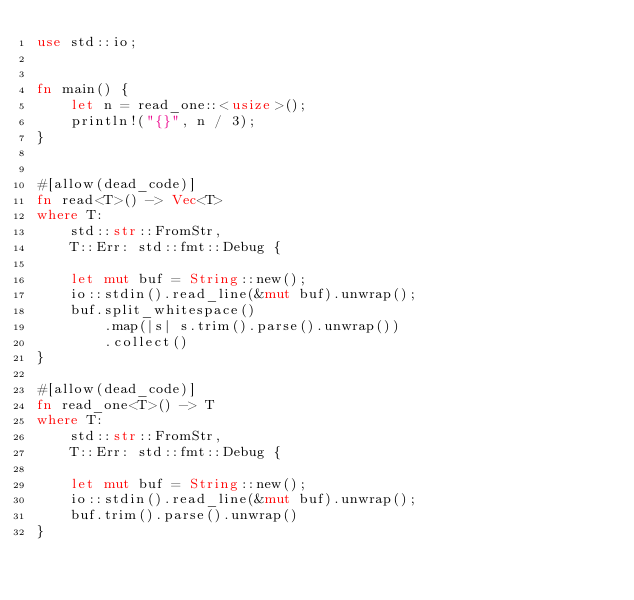<code> <loc_0><loc_0><loc_500><loc_500><_Rust_>use std::io;


fn main() {
    let n = read_one::<usize>();
    println!("{}", n / 3);
}


#[allow(dead_code)]
fn read<T>() -> Vec<T>
where T:
    std::str::FromStr,
    T::Err: std::fmt::Debug {

    let mut buf = String::new();
    io::stdin().read_line(&mut buf).unwrap();
    buf.split_whitespace()
        .map(|s| s.trim().parse().unwrap())
        .collect()
}

#[allow(dead_code)]
fn read_one<T>() -> T
where T:
    std::str::FromStr,
    T::Err: std::fmt::Debug {

    let mut buf = String::new();
    io::stdin().read_line(&mut buf).unwrap();
    buf.trim().parse().unwrap()
}</code> 